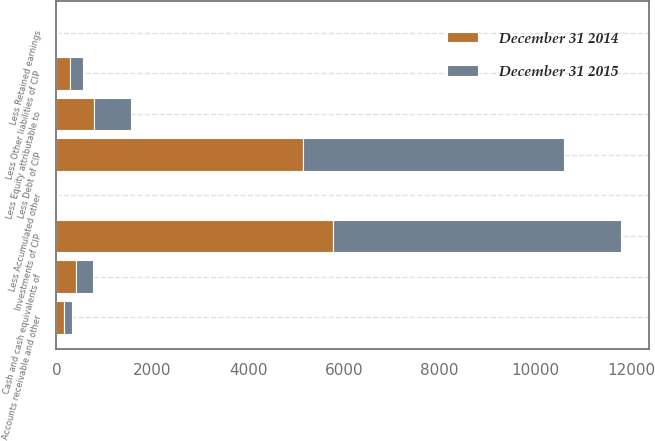Convert chart. <chart><loc_0><loc_0><loc_500><loc_500><stacked_bar_chart><ecel><fcel>Cash and cash equivalents of<fcel>Accounts receivable and other<fcel>Investments of CIP<fcel>Less Debt of CIP<fcel>Less Other liabilities of CIP<fcel>Less Retained earnings<fcel>Less Accumulated other<fcel>Less Equity attributable to<nl><fcel>December 31 2015<fcel>363.3<fcel>173.5<fcel>6016.1<fcel>5437<fcel>273.7<fcel>20.1<fcel>20.1<fcel>768.8<nl><fcel>December 31 2014<fcel>404<fcel>161.3<fcel>5762.8<fcel>5149.6<fcel>280.9<fcel>20.3<fcel>20.2<fcel>781.2<nl></chart> 